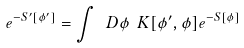Convert formula to latex. <formula><loc_0><loc_0><loc_500><loc_500>e ^ { - S ^ { \prime } [ \phi ^ { \prime } ] } = \int \ D \phi \ K [ \phi ^ { \prime } , \phi ] e ^ { - S [ \phi ] }</formula> 